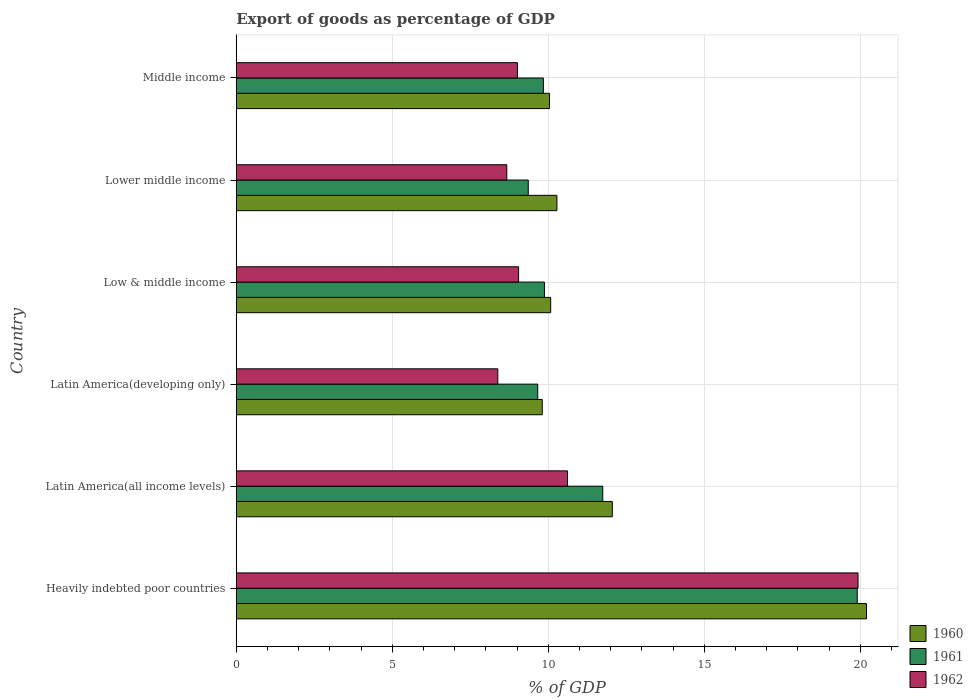How many different coloured bars are there?
Make the answer very short. 3. How many groups of bars are there?
Give a very brief answer. 6. Are the number of bars per tick equal to the number of legend labels?
Your response must be concise. Yes. How many bars are there on the 6th tick from the bottom?
Ensure brevity in your answer.  3. What is the label of the 2nd group of bars from the top?
Ensure brevity in your answer.  Lower middle income. What is the export of goods as percentage of GDP in 1961 in Latin America(all income levels)?
Ensure brevity in your answer.  11.75. Across all countries, what is the maximum export of goods as percentage of GDP in 1960?
Provide a short and direct response. 20.2. Across all countries, what is the minimum export of goods as percentage of GDP in 1961?
Provide a short and direct response. 9.36. In which country was the export of goods as percentage of GDP in 1961 maximum?
Your response must be concise. Heavily indebted poor countries. In which country was the export of goods as percentage of GDP in 1962 minimum?
Your answer should be very brief. Latin America(developing only). What is the total export of goods as percentage of GDP in 1962 in the graph?
Provide a short and direct response. 65.67. What is the difference between the export of goods as percentage of GDP in 1962 in Heavily indebted poor countries and that in Middle income?
Your answer should be very brief. 10.92. What is the difference between the export of goods as percentage of GDP in 1960 in Middle income and the export of goods as percentage of GDP in 1962 in Lower middle income?
Provide a succinct answer. 1.37. What is the average export of goods as percentage of GDP in 1960 per country?
Provide a succinct answer. 12.08. What is the difference between the export of goods as percentage of GDP in 1960 and export of goods as percentage of GDP in 1961 in Middle income?
Offer a very short reply. 0.2. In how many countries, is the export of goods as percentage of GDP in 1961 greater than 12 %?
Your response must be concise. 1. What is the ratio of the export of goods as percentage of GDP in 1962 in Latin America(all income levels) to that in Middle income?
Provide a succinct answer. 1.18. Is the difference between the export of goods as percentage of GDP in 1960 in Latin America(developing only) and Lower middle income greater than the difference between the export of goods as percentage of GDP in 1961 in Latin America(developing only) and Lower middle income?
Offer a terse response. No. What is the difference between the highest and the second highest export of goods as percentage of GDP in 1961?
Your answer should be compact. 8.16. What is the difference between the highest and the lowest export of goods as percentage of GDP in 1962?
Ensure brevity in your answer.  11.55. What does the 3rd bar from the bottom in Heavily indebted poor countries represents?
Give a very brief answer. 1962. Is it the case that in every country, the sum of the export of goods as percentage of GDP in 1962 and export of goods as percentage of GDP in 1960 is greater than the export of goods as percentage of GDP in 1961?
Give a very brief answer. Yes. What is the difference between two consecutive major ticks on the X-axis?
Provide a short and direct response. 5. Does the graph contain grids?
Keep it short and to the point. Yes. How many legend labels are there?
Make the answer very short. 3. How are the legend labels stacked?
Make the answer very short. Vertical. What is the title of the graph?
Give a very brief answer. Export of goods as percentage of GDP. What is the label or title of the X-axis?
Your response must be concise. % of GDP. What is the label or title of the Y-axis?
Keep it short and to the point. Country. What is the % of GDP of 1960 in Heavily indebted poor countries?
Offer a terse response. 20.2. What is the % of GDP of 1961 in Heavily indebted poor countries?
Your answer should be compact. 19.9. What is the % of GDP in 1962 in Heavily indebted poor countries?
Provide a short and direct response. 19.93. What is the % of GDP in 1960 in Latin America(all income levels)?
Make the answer very short. 12.05. What is the % of GDP in 1961 in Latin America(all income levels)?
Your answer should be very brief. 11.75. What is the % of GDP in 1962 in Latin America(all income levels)?
Your response must be concise. 10.62. What is the % of GDP of 1960 in Latin America(developing only)?
Give a very brief answer. 9.81. What is the % of GDP in 1961 in Latin America(developing only)?
Provide a succinct answer. 9.66. What is the % of GDP in 1962 in Latin America(developing only)?
Your response must be concise. 8.38. What is the % of GDP in 1960 in Low & middle income?
Provide a short and direct response. 10.08. What is the % of GDP of 1961 in Low & middle income?
Your answer should be compact. 9.88. What is the % of GDP of 1962 in Low & middle income?
Provide a short and direct response. 9.05. What is the % of GDP in 1960 in Lower middle income?
Keep it short and to the point. 10.28. What is the % of GDP in 1961 in Lower middle income?
Keep it short and to the point. 9.36. What is the % of GDP of 1962 in Lower middle income?
Give a very brief answer. 8.67. What is the % of GDP in 1960 in Middle income?
Your answer should be very brief. 10.04. What is the % of GDP in 1961 in Middle income?
Offer a terse response. 9.84. What is the % of GDP in 1962 in Middle income?
Ensure brevity in your answer.  9.01. Across all countries, what is the maximum % of GDP in 1960?
Your answer should be compact. 20.2. Across all countries, what is the maximum % of GDP in 1961?
Provide a short and direct response. 19.9. Across all countries, what is the maximum % of GDP of 1962?
Provide a succinct answer. 19.93. Across all countries, what is the minimum % of GDP of 1960?
Make the answer very short. 9.81. Across all countries, what is the minimum % of GDP of 1961?
Your answer should be very brief. 9.36. Across all countries, what is the minimum % of GDP of 1962?
Offer a terse response. 8.38. What is the total % of GDP in 1960 in the graph?
Provide a succinct answer. 72.46. What is the total % of GDP of 1961 in the graph?
Provide a short and direct response. 70.4. What is the total % of GDP of 1962 in the graph?
Offer a terse response. 65.67. What is the difference between the % of GDP in 1960 in Heavily indebted poor countries and that in Latin America(all income levels)?
Keep it short and to the point. 8.15. What is the difference between the % of GDP of 1961 in Heavily indebted poor countries and that in Latin America(all income levels)?
Make the answer very short. 8.16. What is the difference between the % of GDP of 1962 in Heavily indebted poor countries and that in Latin America(all income levels)?
Provide a short and direct response. 9.31. What is the difference between the % of GDP in 1960 in Heavily indebted poor countries and that in Latin America(developing only)?
Provide a succinct answer. 10.39. What is the difference between the % of GDP in 1961 in Heavily indebted poor countries and that in Latin America(developing only)?
Give a very brief answer. 10.24. What is the difference between the % of GDP in 1962 in Heavily indebted poor countries and that in Latin America(developing only)?
Ensure brevity in your answer.  11.55. What is the difference between the % of GDP in 1960 in Heavily indebted poor countries and that in Low & middle income?
Offer a terse response. 10.12. What is the difference between the % of GDP in 1961 in Heavily indebted poor countries and that in Low & middle income?
Your response must be concise. 10.03. What is the difference between the % of GDP in 1962 in Heavily indebted poor countries and that in Low & middle income?
Provide a short and direct response. 10.88. What is the difference between the % of GDP of 1960 in Heavily indebted poor countries and that in Lower middle income?
Offer a terse response. 9.92. What is the difference between the % of GDP of 1961 in Heavily indebted poor countries and that in Lower middle income?
Give a very brief answer. 10.54. What is the difference between the % of GDP in 1962 in Heavily indebted poor countries and that in Lower middle income?
Ensure brevity in your answer.  11.26. What is the difference between the % of GDP in 1960 in Heavily indebted poor countries and that in Middle income?
Provide a short and direct response. 10.16. What is the difference between the % of GDP in 1961 in Heavily indebted poor countries and that in Middle income?
Provide a succinct answer. 10.06. What is the difference between the % of GDP of 1962 in Heavily indebted poor countries and that in Middle income?
Keep it short and to the point. 10.92. What is the difference between the % of GDP in 1960 in Latin America(all income levels) and that in Latin America(developing only)?
Your response must be concise. 2.25. What is the difference between the % of GDP of 1961 in Latin America(all income levels) and that in Latin America(developing only)?
Provide a succinct answer. 2.08. What is the difference between the % of GDP in 1962 in Latin America(all income levels) and that in Latin America(developing only)?
Keep it short and to the point. 2.23. What is the difference between the % of GDP of 1960 in Latin America(all income levels) and that in Low & middle income?
Your answer should be compact. 1.98. What is the difference between the % of GDP in 1961 in Latin America(all income levels) and that in Low & middle income?
Give a very brief answer. 1.87. What is the difference between the % of GDP of 1962 in Latin America(all income levels) and that in Low & middle income?
Give a very brief answer. 1.57. What is the difference between the % of GDP in 1960 in Latin America(all income levels) and that in Lower middle income?
Provide a short and direct response. 1.78. What is the difference between the % of GDP in 1961 in Latin America(all income levels) and that in Lower middle income?
Give a very brief answer. 2.39. What is the difference between the % of GDP of 1962 in Latin America(all income levels) and that in Lower middle income?
Give a very brief answer. 1.95. What is the difference between the % of GDP of 1960 in Latin America(all income levels) and that in Middle income?
Offer a terse response. 2.01. What is the difference between the % of GDP in 1961 in Latin America(all income levels) and that in Middle income?
Offer a terse response. 1.9. What is the difference between the % of GDP in 1962 in Latin America(all income levels) and that in Middle income?
Ensure brevity in your answer.  1.6. What is the difference between the % of GDP of 1960 in Latin America(developing only) and that in Low & middle income?
Offer a very short reply. -0.27. What is the difference between the % of GDP in 1961 in Latin America(developing only) and that in Low & middle income?
Your response must be concise. -0.21. What is the difference between the % of GDP in 1962 in Latin America(developing only) and that in Low & middle income?
Your answer should be compact. -0.67. What is the difference between the % of GDP of 1960 in Latin America(developing only) and that in Lower middle income?
Keep it short and to the point. -0.47. What is the difference between the % of GDP of 1961 in Latin America(developing only) and that in Lower middle income?
Your answer should be compact. 0.3. What is the difference between the % of GDP in 1962 in Latin America(developing only) and that in Lower middle income?
Provide a succinct answer. -0.29. What is the difference between the % of GDP in 1960 in Latin America(developing only) and that in Middle income?
Provide a succinct answer. -0.23. What is the difference between the % of GDP in 1961 in Latin America(developing only) and that in Middle income?
Your answer should be very brief. -0.18. What is the difference between the % of GDP in 1962 in Latin America(developing only) and that in Middle income?
Give a very brief answer. -0.63. What is the difference between the % of GDP in 1960 in Low & middle income and that in Lower middle income?
Provide a succinct answer. -0.2. What is the difference between the % of GDP of 1961 in Low & middle income and that in Lower middle income?
Ensure brevity in your answer.  0.52. What is the difference between the % of GDP in 1962 in Low & middle income and that in Lower middle income?
Your answer should be compact. 0.38. What is the difference between the % of GDP in 1960 in Low & middle income and that in Middle income?
Make the answer very short. 0.04. What is the difference between the % of GDP in 1961 in Low & middle income and that in Middle income?
Provide a short and direct response. 0.03. What is the difference between the % of GDP of 1962 in Low & middle income and that in Middle income?
Give a very brief answer. 0.04. What is the difference between the % of GDP of 1960 in Lower middle income and that in Middle income?
Offer a very short reply. 0.24. What is the difference between the % of GDP of 1961 in Lower middle income and that in Middle income?
Provide a short and direct response. -0.48. What is the difference between the % of GDP of 1962 in Lower middle income and that in Middle income?
Offer a very short reply. -0.34. What is the difference between the % of GDP of 1960 in Heavily indebted poor countries and the % of GDP of 1961 in Latin America(all income levels)?
Give a very brief answer. 8.45. What is the difference between the % of GDP of 1960 in Heavily indebted poor countries and the % of GDP of 1962 in Latin America(all income levels)?
Your answer should be compact. 9.58. What is the difference between the % of GDP of 1961 in Heavily indebted poor countries and the % of GDP of 1962 in Latin America(all income levels)?
Provide a short and direct response. 9.29. What is the difference between the % of GDP in 1960 in Heavily indebted poor countries and the % of GDP in 1961 in Latin America(developing only)?
Your answer should be compact. 10.54. What is the difference between the % of GDP in 1960 in Heavily indebted poor countries and the % of GDP in 1962 in Latin America(developing only)?
Your response must be concise. 11.82. What is the difference between the % of GDP in 1961 in Heavily indebted poor countries and the % of GDP in 1962 in Latin America(developing only)?
Offer a very short reply. 11.52. What is the difference between the % of GDP in 1960 in Heavily indebted poor countries and the % of GDP in 1961 in Low & middle income?
Offer a terse response. 10.32. What is the difference between the % of GDP of 1960 in Heavily indebted poor countries and the % of GDP of 1962 in Low & middle income?
Offer a very short reply. 11.15. What is the difference between the % of GDP in 1961 in Heavily indebted poor countries and the % of GDP in 1962 in Low & middle income?
Offer a very short reply. 10.85. What is the difference between the % of GDP in 1960 in Heavily indebted poor countries and the % of GDP in 1961 in Lower middle income?
Ensure brevity in your answer.  10.84. What is the difference between the % of GDP in 1960 in Heavily indebted poor countries and the % of GDP in 1962 in Lower middle income?
Offer a very short reply. 11.53. What is the difference between the % of GDP in 1961 in Heavily indebted poor countries and the % of GDP in 1962 in Lower middle income?
Your response must be concise. 11.23. What is the difference between the % of GDP in 1960 in Heavily indebted poor countries and the % of GDP in 1961 in Middle income?
Provide a short and direct response. 10.36. What is the difference between the % of GDP in 1960 in Heavily indebted poor countries and the % of GDP in 1962 in Middle income?
Keep it short and to the point. 11.19. What is the difference between the % of GDP in 1961 in Heavily indebted poor countries and the % of GDP in 1962 in Middle income?
Your answer should be compact. 10.89. What is the difference between the % of GDP of 1960 in Latin America(all income levels) and the % of GDP of 1961 in Latin America(developing only)?
Provide a short and direct response. 2.39. What is the difference between the % of GDP in 1960 in Latin America(all income levels) and the % of GDP in 1962 in Latin America(developing only)?
Give a very brief answer. 3.67. What is the difference between the % of GDP in 1961 in Latin America(all income levels) and the % of GDP in 1962 in Latin America(developing only)?
Provide a short and direct response. 3.36. What is the difference between the % of GDP of 1960 in Latin America(all income levels) and the % of GDP of 1961 in Low & middle income?
Your response must be concise. 2.18. What is the difference between the % of GDP in 1960 in Latin America(all income levels) and the % of GDP in 1962 in Low & middle income?
Provide a short and direct response. 3. What is the difference between the % of GDP of 1961 in Latin America(all income levels) and the % of GDP of 1962 in Low & middle income?
Offer a very short reply. 2.7. What is the difference between the % of GDP of 1960 in Latin America(all income levels) and the % of GDP of 1961 in Lower middle income?
Offer a very short reply. 2.69. What is the difference between the % of GDP of 1960 in Latin America(all income levels) and the % of GDP of 1962 in Lower middle income?
Provide a short and direct response. 3.38. What is the difference between the % of GDP of 1961 in Latin America(all income levels) and the % of GDP of 1962 in Lower middle income?
Your answer should be very brief. 3.08. What is the difference between the % of GDP of 1960 in Latin America(all income levels) and the % of GDP of 1961 in Middle income?
Provide a succinct answer. 2.21. What is the difference between the % of GDP of 1960 in Latin America(all income levels) and the % of GDP of 1962 in Middle income?
Offer a very short reply. 3.04. What is the difference between the % of GDP of 1961 in Latin America(all income levels) and the % of GDP of 1962 in Middle income?
Ensure brevity in your answer.  2.73. What is the difference between the % of GDP of 1960 in Latin America(developing only) and the % of GDP of 1961 in Low & middle income?
Offer a terse response. -0.07. What is the difference between the % of GDP in 1960 in Latin America(developing only) and the % of GDP in 1962 in Low & middle income?
Your answer should be very brief. 0.76. What is the difference between the % of GDP of 1961 in Latin America(developing only) and the % of GDP of 1962 in Low & middle income?
Offer a very short reply. 0.61. What is the difference between the % of GDP of 1960 in Latin America(developing only) and the % of GDP of 1961 in Lower middle income?
Provide a short and direct response. 0.45. What is the difference between the % of GDP in 1960 in Latin America(developing only) and the % of GDP in 1962 in Lower middle income?
Your answer should be compact. 1.14. What is the difference between the % of GDP of 1961 in Latin America(developing only) and the % of GDP of 1962 in Lower middle income?
Your answer should be very brief. 0.99. What is the difference between the % of GDP of 1960 in Latin America(developing only) and the % of GDP of 1961 in Middle income?
Give a very brief answer. -0.04. What is the difference between the % of GDP in 1960 in Latin America(developing only) and the % of GDP in 1962 in Middle income?
Provide a short and direct response. 0.8. What is the difference between the % of GDP of 1961 in Latin America(developing only) and the % of GDP of 1962 in Middle income?
Provide a succinct answer. 0.65. What is the difference between the % of GDP in 1960 in Low & middle income and the % of GDP in 1961 in Lower middle income?
Offer a terse response. 0.72. What is the difference between the % of GDP of 1960 in Low & middle income and the % of GDP of 1962 in Lower middle income?
Make the answer very short. 1.41. What is the difference between the % of GDP of 1961 in Low & middle income and the % of GDP of 1962 in Lower middle income?
Provide a succinct answer. 1.21. What is the difference between the % of GDP of 1960 in Low & middle income and the % of GDP of 1961 in Middle income?
Provide a short and direct response. 0.23. What is the difference between the % of GDP in 1960 in Low & middle income and the % of GDP in 1962 in Middle income?
Give a very brief answer. 1.07. What is the difference between the % of GDP in 1961 in Low & middle income and the % of GDP in 1962 in Middle income?
Your answer should be very brief. 0.86. What is the difference between the % of GDP in 1960 in Lower middle income and the % of GDP in 1961 in Middle income?
Your answer should be very brief. 0.43. What is the difference between the % of GDP in 1960 in Lower middle income and the % of GDP in 1962 in Middle income?
Make the answer very short. 1.27. What is the difference between the % of GDP of 1961 in Lower middle income and the % of GDP of 1962 in Middle income?
Offer a terse response. 0.35. What is the average % of GDP of 1960 per country?
Ensure brevity in your answer.  12.08. What is the average % of GDP of 1961 per country?
Ensure brevity in your answer.  11.73. What is the average % of GDP of 1962 per country?
Ensure brevity in your answer.  10.94. What is the difference between the % of GDP of 1960 and % of GDP of 1961 in Heavily indebted poor countries?
Your answer should be very brief. 0.3. What is the difference between the % of GDP in 1960 and % of GDP in 1962 in Heavily indebted poor countries?
Offer a very short reply. 0.27. What is the difference between the % of GDP of 1961 and % of GDP of 1962 in Heavily indebted poor countries?
Provide a succinct answer. -0.03. What is the difference between the % of GDP in 1960 and % of GDP in 1961 in Latin America(all income levels)?
Your response must be concise. 0.31. What is the difference between the % of GDP of 1960 and % of GDP of 1962 in Latin America(all income levels)?
Provide a succinct answer. 1.44. What is the difference between the % of GDP in 1961 and % of GDP in 1962 in Latin America(all income levels)?
Give a very brief answer. 1.13. What is the difference between the % of GDP in 1960 and % of GDP in 1961 in Latin America(developing only)?
Your answer should be very brief. 0.15. What is the difference between the % of GDP of 1960 and % of GDP of 1962 in Latin America(developing only)?
Give a very brief answer. 1.42. What is the difference between the % of GDP in 1961 and % of GDP in 1962 in Latin America(developing only)?
Keep it short and to the point. 1.28. What is the difference between the % of GDP in 1960 and % of GDP in 1961 in Low & middle income?
Make the answer very short. 0.2. What is the difference between the % of GDP of 1960 and % of GDP of 1962 in Low & middle income?
Give a very brief answer. 1.03. What is the difference between the % of GDP in 1961 and % of GDP in 1962 in Low & middle income?
Offer a very short reply. 0.83. What is the difference between the % of GDP of 1960 and % of GDP of 1961 in Lower middle income?
Keep it short and to the point. 0.92. What is the difference between the % of GDP in 1960 and % of GDP in 1962 in Lower middle income?
Offer a terse response. 1.61. What is the difference between the % of GDP in 1961 and % of GDP in 1962 in Lower middle income?
Offer a very short reply. 0.69. What is the difference between the % of GDP in 1960 and % of GDP in 1961 in Middle income?
Give a very brief answer. 0.2. What is the difference between the % of GDP of 1960 and % of GDP of 1962 in Middle income?
Offer a very short reply. 1.03. What is the difference between the % of GDP in 1961 and % of GDP in 1962 in Middle income?
Provide a succinct answer. 0.83. What is the ratio of the % of GDP in 1960 in Heavily indebted poor countries to that in Latin America(all income levels)?
Make the answer very short. 1.68. What is the ratio of the % of GDP in 1961 in Heavily indebted poor countries to that in Latin America(all income levels)?
Provide a short and direct response. 1.69. What is the ratio of the % of GDP in 1962 in Heavily indebted poor countries to that in Latin America(all income levels)?
Your response must be concise. 1.88. What is the ratio of the % of GDP of 1960 in Heavily indebted poor countries to that in Latin America(developing only)?
Offer a terse response. 2.06. What is the ratio of the % of GDP of 1961 in Heavily indebted poor countries to that in Latin America(developing only)?
Offer a very short reply. 2.06. What is the ratio of the % of GDP in 1962 in Heavily indebted poor countries to that in Latin America(developing only)?
Your answer should be compact. 2.38. What is the ratio of the % of GDP of 1960 in Heavily indebted poor countries to that in Low & middle income?
Provide a short and direct response. 2. What is the ratio of the % of GDP of 1961 in Heavily indebted poor countries to that in Low & middle income?
Provide a short and direct response. 2.02. What is the ratio of the % of GDP of 1962 in Heavily indebted poor countries to that in Low & middle income?
Your answer should be compact. 2.2. What is the ratio of the % of GDP in 1960 in Heavily indebted poor countries to that in Lower middle income?
Make the answer very short. 1.97. What is the ratio of the % of GDP in 1961 in Heavily indebted poor countries to that in Lower middle income?
Your answer should be compact. 2.13. What is the ratio of the % of GDP in 1962 in Heavily indebted poor countries to that in Lower middle income?
Offer a very short reply. 2.3. What is the ratio of the % of GDP of 1960 in Heavily indebted poor countries to that in Middle income?
Make the answer very short. 2.01. What is the ratio of the % of GDP of 1961 in Heavily indebted poor countries to that in Middle income?
Provide a succinct answer. 2.02. What is the ratio of the % of GDP in 1962 in Heavily indebted poor countries to that in Middle income?
Your answer should be very brief. 2.21. What is the ratio of the % of GDP of 1960 in Latin America(all income levels) to that in Latin America(developing only)?
Your answer should be compact. 1.23. What is the ratio of the % of GDP in 1961 in Latin America(all income levels) to that in Latin America(developing only)?
Your answer should be compact. 1.22. What is the ratio of the % of GDP in 1962 in Latin America(all income levels) to that in Latin America(developing only)?
Your answer should be very brief. 1.27. What is the ratio of the % of GDP of 1960 in Latin America(all income levels) to that in Low & middle income?
Offer a terse response. 1.2. What is the ratio of the % of GDP in 1961 in Latin America(all income levels) to that in Low & middle income?
Your response must be concise. 1.19. What is the ratio of the % of GDP in 1962 in Latin America(all income levels) to that in Low & middle income?
Your response must be concise. 1.17. What is the ratio of the % of GDP of 1960 in Latin America(all income levels) to that in Lower middle income?
Ensure brevity in your answer.  1.17. What is the ratio of the % of GDP in 1961 in Latin America(all income levels) to that in Lower middle income?
Offer a very short reply. 1.26. What is the ratio of the % of GDP in 1962 in Latin America(all income levels) to that in Lower middle income?
Ensure brevity in your answer.  1.22. What is the ratio of the % of GDP of 1960 in Latin America(all income levels) to that in Middle income?
Provide a short and direct response. 1.2. What is the ratio of the % of GDP of 1961 in Latin America(all income levels) to that in Middle income?
Your answer should be compact. 1.19. What is the ratio of the % of GDP of 1962 in Latin America(all income levels) to that in Middle income?
Make the answer very short. 1.18. What is the ratio of the % of GDP of 1960 in Latin America(developing only) to that in Low & middle income?
Your answer should be compact. 0.97. What is the ratio of the % of GDP of 1961 in Latin America(developing only) to that in Low & middle income?
Make the answer very short. 0.98. What is the ratio of the % of GDP of 1962 in Latin America(developing only) to that in Low & middle income?
Your response must be concise. 0.93. What is the ratio of the % of GDP of 1960 in Latin America(developing only) to that in Lower middle income?
Ensure brevity in your answer.  0.95. What is the ratio of the % of GDP in 1961 in Latin America(developing only) to that in Lower middle income?
Provide a succinct answer. 1.03. What is the ratio of the % of GDP in 1962 in Latin America(developing only) to that in Lower middle income?
Give a very brief answer. 0.97. What is the ratio of the % of GDP in 1960 in Latin America(developing only) to that in Middle income?
Provide a short and direct response. 0.98. What is the ratio of the % of GDP of 1961 in Latin America(developing only) to that in Middle income?
Your answer should be very brief. 0.98. What is the ratio of the % of GDP of 1962 in Latin America(developing only) to that in Middle income?
Keep it short and to the point. 0.93. What is the ratio of the % of GDP of 1960 in Low & middle income to that in Lower middle income?
Offer a terse response. 0.98. What is the ratio of the % of GDP in 1961 in Low & middle income to that in Lower middle income?
Provide a short and direct response. 1.06. What is the ratio of the % of GDP in 1962 in Low & middle income to that in Lower middle income?
Ensure brevity in your answer.  1.04. What is the ratio of the % of GDP of 1962 in Low & middle income to that in Middle income?
Provide a succinct answer. 1. What is the ratio of the % of GDP in 1960 in Lower middle income to that in Middle income?
Keep it short and to the point. 1.02. What is the ratio of the % of GDP of 1961 in Lower middle income to that in Middle income?
Your answer should be very brief. 0.95. What is the ratio of the % of GDP in 1962 in Lower middle income to that in Middle income?
Ensure brevity in your answer.  0.96. What is the difference between the highest and the second highest % of GDP of 1960?
Offer a very short reply. 8.15. What is the difference between the highest and the second highest % of GDP in 1961?
Give a very brief answer. 8.16. What is the difference between the highest and the second highest % of GDP in 1962?
Your response must be concise. 9.31. What is the difference between the highest and the lowest % of GDP in 1960?
Ensure brevity in your answer.  10.39. What is the difference between the highest and the lowest % of GDP of 1961?
Offer a terse response. 10.54. What is the difference between the highest and the lowest % of GDP of 1962?
Provide a short and direct response. 11.55. 